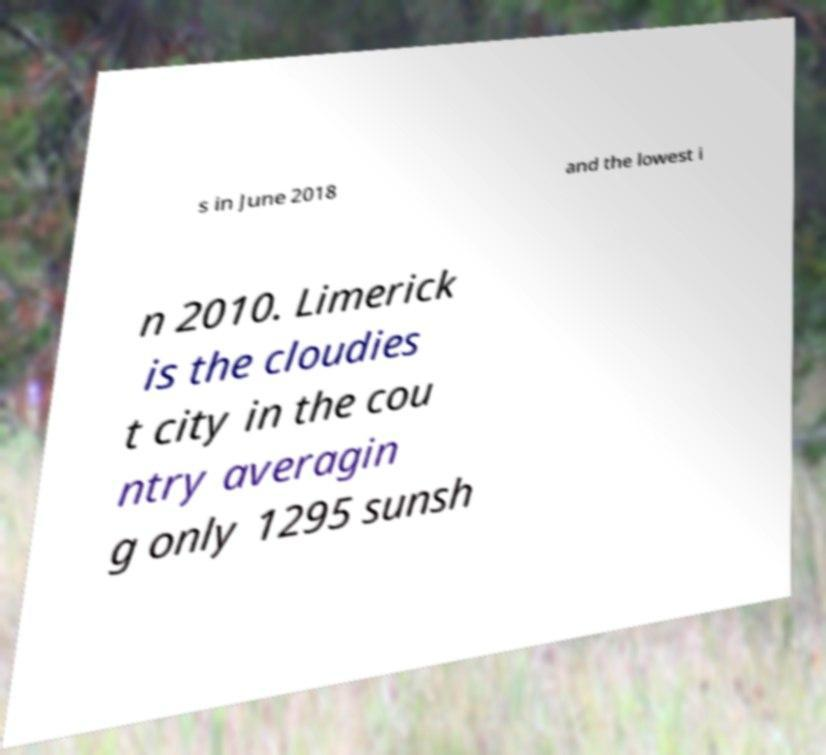For documentation purposes, I need the text within this image transcribed. Could you provide that? s in June 2018 and the lowest i n 2010. Limerick is the cloudies t city in the cou ntry averagin g only 1295 sunsh 